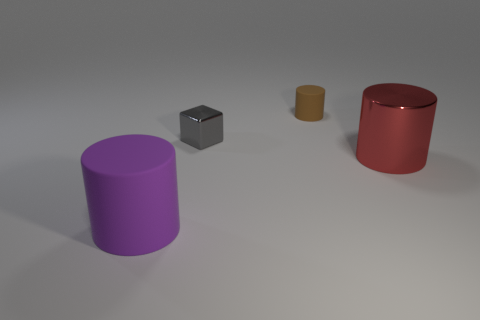There is a cylinder that is both in front of the small brown matte thing and to the right of the small gray metallic cube; what is it made of?
Give a very brief answer. Metal. Does the tiny shiny thing have the same color as the large cylinder that is on the right side of the big purple matte object?
Offer a terse response. No. The cylinder that is the same material as the gray cube is what size?
Keep it short and to the point. Large. What number of objects are large objects that are behind the large matte thing or tiny matte things?
Give a very brief answer. 2. Is the small gray thing made of the same material as the big thing to the right of the large rubber thing?
Provide a succinct answer. Yes. Is there a large object that has the same material as the tiny cylinder?
Your answer should be very brief. Yes. How many objects are large cylinders that are in front of the red cylinder or cylinders left of the gray thing?
Give a very brief answer. 1. There is a tiny brown object; is its shape the same as the large object that is behind the large purple rubber object?
Offer a terse response. Yes. How many other objects are there of the same shape as the tiny matte thing?
Your response must be concise. 2. What number of objects are brown cylinders or big purple cylinders?
Provide a succinct answer. 2. 